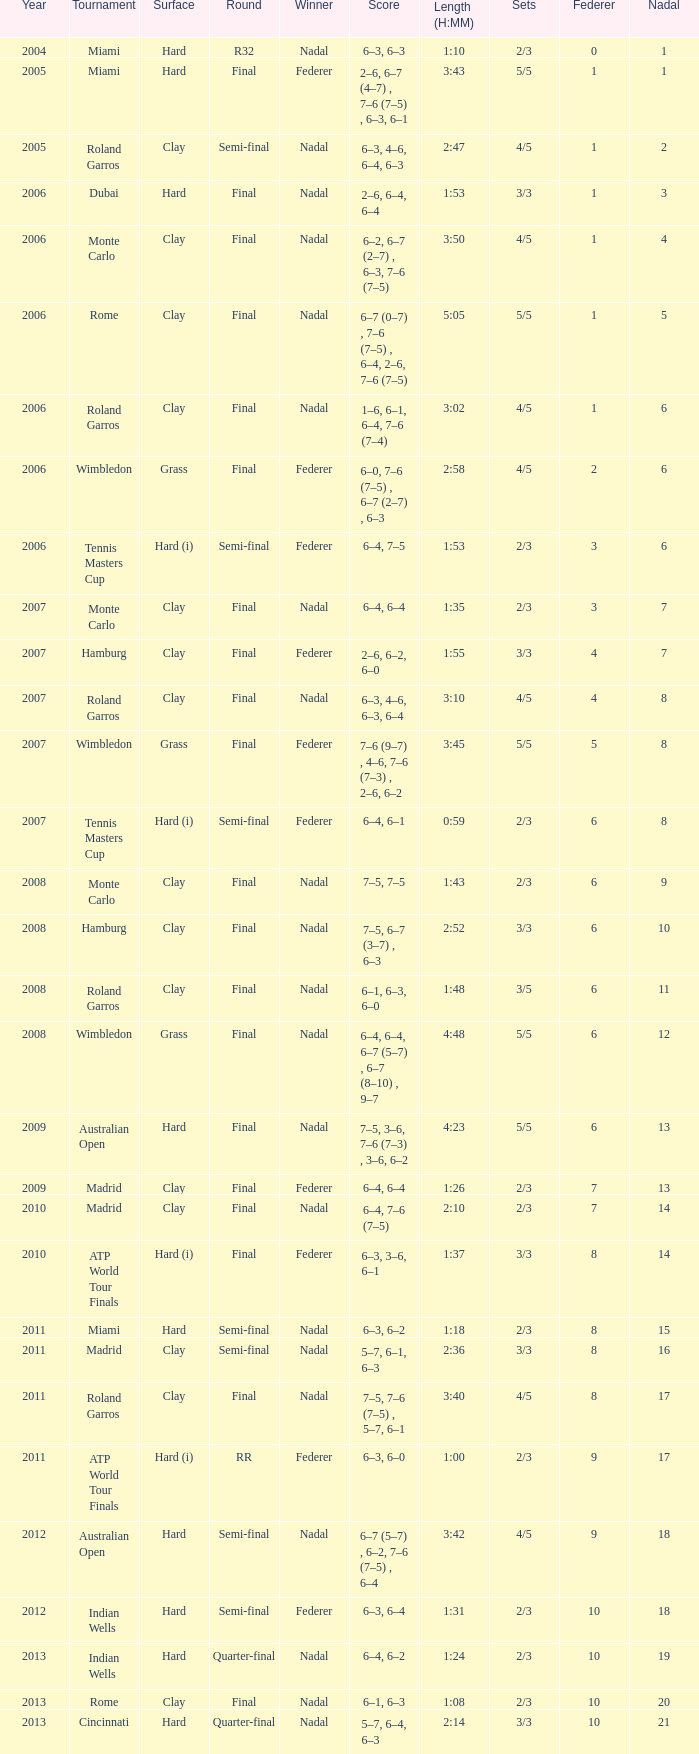Help me parse the entirety of this table. {'header': ['Year', 'Tournament', 'Surface', 'Round', 'Winner', 'Score', 'Length (H:MM)', 'Sets', 'Federer', 'Nadal'], 'rows': [['2004', 'Miami', 'Hard', 'R32', 'Nadal', '6–3, 6–3', '1:10', '2/3', '0', '1'], ['2005', 'Miami', 'Hard', 'Final', 'Federer', '2–6, 6–7 (4–7) , 7–6 (7–5) , 6–3, 6–1', '3:43', '5/5', '1', '1'], ['2005', 'Roland Garros', 'Clay', 'Semi-final', 'Nadal', '6–3, 4–6, 6–4, 6–3', '2:47', '4/5', '1', '2'], ['2006', 'Dubai', 'Hard', 'Final', 'Nadal', '2–6, 6–4, 6–4', '1:53', '3/3', '1', '3'], ['2006', 'Monte Carlo', 'Clay', 'Final', 'Nadal', '6–2, 6–7 (2–7) , 6–3, 7–6 (7–5)', '3:50', '4/5', '1', '4'], ['2006', 'Rome', 'Clay', 'Final', 'Nadal', '6–7 (0–7) , 7–6 (7–5) , 6–4, 2–6, 7–6 (7–5)', '5:05', '5/5', '1', '5'], ['2006', 'Roland Garros', 'Clay', 'Final', 'Nadal', '1–6, 6–1, 6–4, 7–6 (7–4)', '3:02', '4/5', '1', '6'], ['2006', 'Wimbledon', 'Grass', 'Final', 'Federer', '6–0, 7–6 (7–5) , 6–7 (2–7) , 6–3', '2:58', '4/5', '2', '6'], ['2006', 'Tennis Masters Cup', 'Hard (i)', 'Semi-final', 'Federer', '6–4, 7–5', '1:53', '2/3', '3', '6'], ['2007', 'Monte Carlo', 'Clay', 'Final', 'Nadal', '6–4, 6–4', '1:35', '2/3', '3', '7'], ['2007', 'Hamburg', 'Clay', 'Final', 'Federer', '2–6, 6–2, 6–0', '1:55', '3/3', '4', '7'], ['2007', 'Roland Garros', 'Clay', 'Final', 'Nadal', '6–3, 4–6, 6–3, 6–4', '3:10', '4/5', '4', '8'], ['2007', 'Wimbledon', 'Grass', 'Final', 'Federer', '7–6 (9–7) , 4–6, 7–6 (7–3) , 2–6, 6–2', '3:45', '5/5', '5', '8'], ['2007', 'Tennis Masters Cup', 'Hard (i)', 'Semi-final', 'Federer', '6–4, 6–1', '0:59', '2/3', '6', '8'], ['2008', 'Monte Carlo', 'Clay', 'Final', 'Nadal', '7–5, 7–5', '1:43', '2/3', '6', '9'], ['2008', 'Hamburg', 'Clay', 'Final', 'Nadal', '7–5, 6–7 (3–7) , 6–3', '2:52', '3/3', '6', '10'], ['2008', 'Roland Garros', 'Clay', 'Final', 'Nadal', '6–1, 6–3, 6–0', '1:48', '3/5', '6', '11'], ['2008', 'Wimbledon', 'Grass', 'Final', 'Nadal', '6–4, 6–4, 6–7 (5–7) , 6–7 (8–10) , 9–7', '4:48', '5/5', '6', '12'], ['2009', 'Australian Open', 'Hard', 'Final', 'Nadal', '7–5, 3–6, 7–6 (7–3) , 3–6, 6–2', '4:23', '5/5', '6', '13'], ['2009', 'Madrid', 'Clay', 'Final', 'Federer', '6–4, 6–4', '1:26', '2/3', '7', '13'], ['2010', 'Madrid', 'Clay', 'Final', 'Nadal', '6–4, 7–6 (7–5)', '2:10', '2/3', '7', '14'], ['2010', 'ATP World Tour Finals', 'Hard (i)', 'Final', 'Federer', '6–3, 3–6, 6–1', '1:37', '3/3', '8', '14'], ['2011', 'Miami', 'Hard', 'Semi-final', 'Nadal', '6–3, 6–2', '1:18', '2/3', '8', '15'], ['2011', 'Madrid', 'Clay', 'Semi-final', 'Nadal', '5–7, 6–1, 6–3', '2:36', '3/3', '8', '16'], ['2011', 'Roland Garros', 'Clay', 'Final', 'Nadal', '7–5, 7–6 (7–5) , 5–7, 6–1', '3:40', '4/5', '8', '17'], ['2011', 'ATP World Tour Finals', 'Hard (i)', 'RR', 'Federer', '6–3, 6–0', '1:00', '2/3', '9', '17'], ['2012', 'Australian Open', 'Hard', 'Semi-final', 'Nadal', '6–7 (5–7) , 6–2, 7–6 (7–5) , 6–4', '3:42', '4/5', '9', '18'], ['2012', 'Indian Wells', 'Hard', 'Semi-final', 'Federer', '6–3, 6–4', '1:31', '2/3', '10', '18'], ['2013', 'Indian Wells', 'Hard', 'Quarter-final', 'Nadal', '6–4, 6–2', '1:24', '2/3', '10', '19'], ['2013', 'Rome', 'Clay', 'Final', 'Nadal', '6–1, 6–3', '1:08', '2/3', '10', '20'], ['2013', 'Cincinnati', 'Hard', 'Quarter-final', 'Nadal', '5–7, 6–4, 6–3', '2:14', '3/3', '10', '21']]} In which sets did federer have 6 points while nadal gained 13 points? 5/5. 